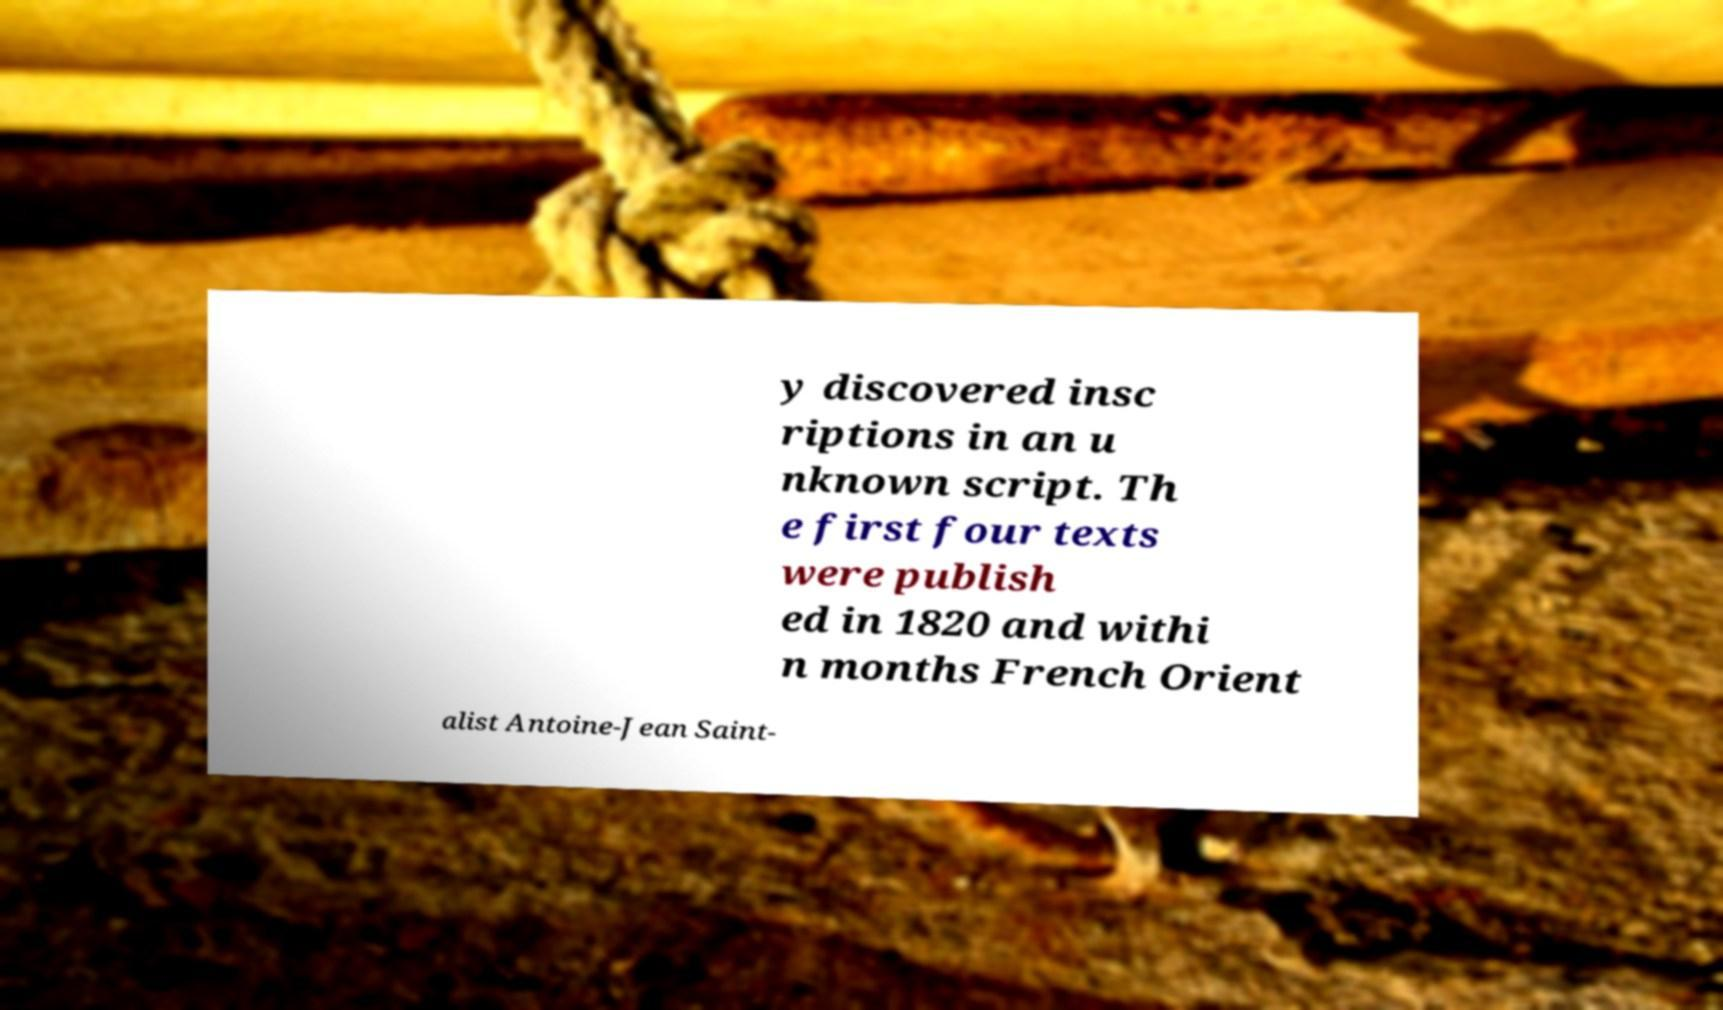Could you extract and type out the text from this image? y discovered insc riptions in an u nknown script. Th e first four texts were publish ed in 1820 and withi n months French Orient alist Antoine-Jean Saint- 